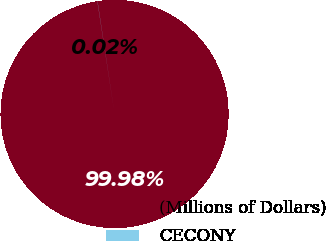Convert chart. <chart><loc_0><loc_0><loc_500><loc_500><pie_chart><fcel>(Millions of Dollars)<fcel>CECONY<nl><fcel>99.98%<fcel>0.02%<nl></chart> 